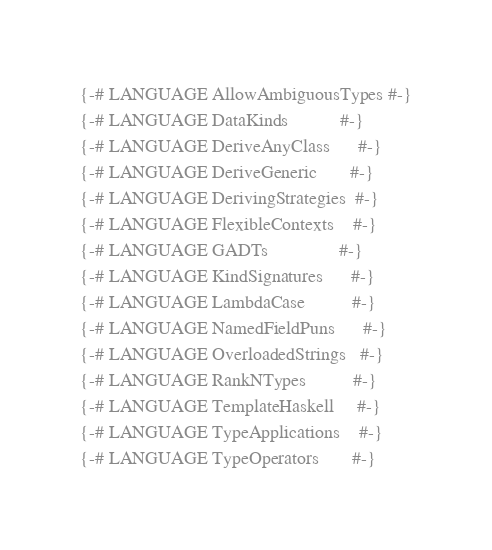Convert code to text. <code><loc_0><loc_0><loc_500><loc_500><_Haskell_>{-# LANGUAGE AllowAmbiguousTypes #-}
{-# LANGUAGE DataKinds           #-}
{-# LANGUAGE DeriveAnyClass      #-}
{-# LANGUAGE DeriveGeneric       #-}
{-# LANGUAGE DerivingStrategies  #-}
{-# LANGUAGE FlexibleContexts    #-}
{-# LANGUAGE GADTs               #-}
{-# LANGUAGE KindSignatures      #-}
{-# LANGUAGE LambdaCase          #-}
{-# LANGUAGE NamedFieldPuns      #-}
{-# LANGUAGE OverloadedStrings   #-}
{-# LANGUAGE RankNTypes          #-}
{-# LANGUAGE TemplateHaskell     #-}
{-# LANGUAGE TypeApplications    #-}
{-# LANGUAGE TypeOperators       #-}</code> 